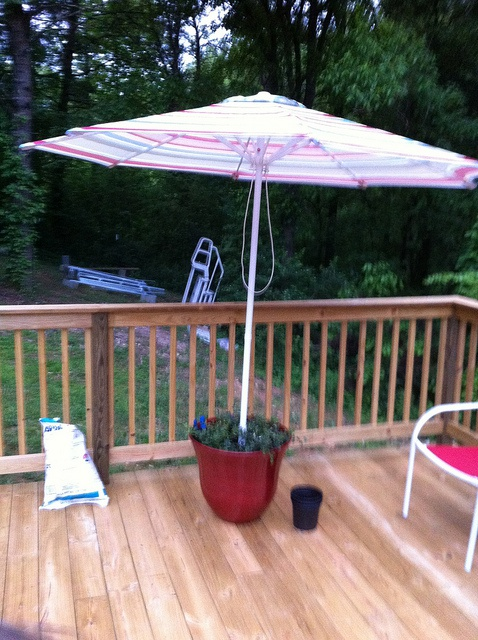Describe the objects in this image and their specific colors. I can see umbrella in navy, lavender, black, and violet tones, potted plant in navy, maroon, brown, gray, and black tones, chair in navy, white, brown, magenta, and darkgray tones, and cup in navy, black, gray, and brown tones in this image. 